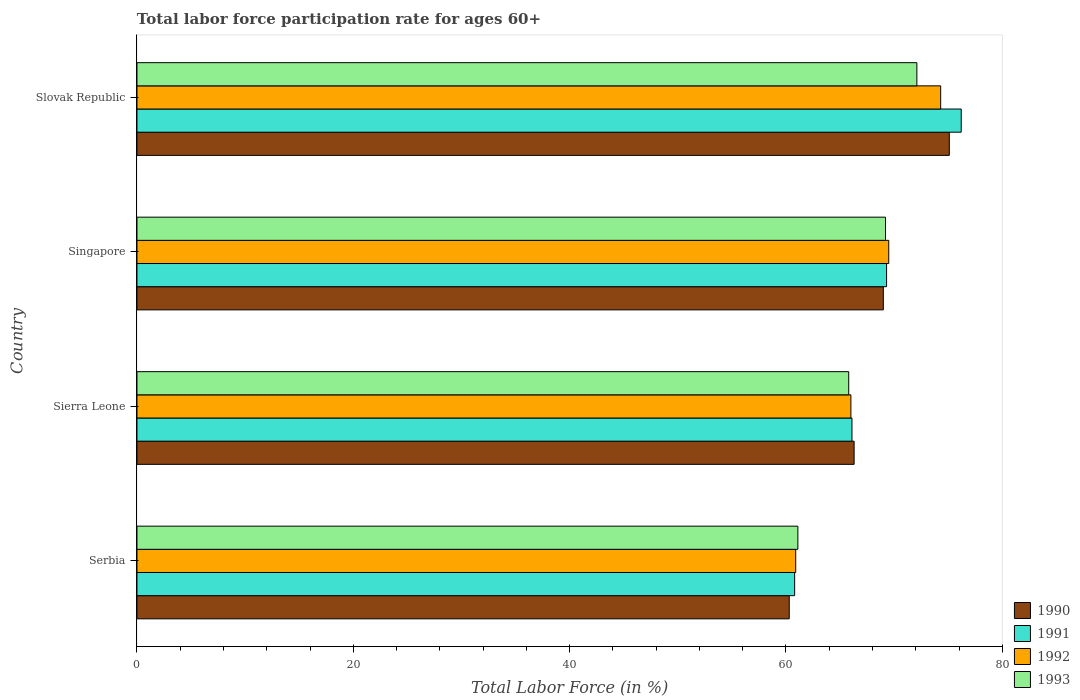How many different coloured bars are there?
Provide a succinct answer. 4. How many groups of bars are there?
Your answer should be very brief. 4. Are the number of bars on each tick of the Y-axis equal?
Offer a terse response. Yes. How many bars are there on the 1st tick from the top?
Offer a terse response. 4. How many bars are there on the 1st tick from the bottom?
Offer a terse response. 4. What is the label of the 1st group of bars from the top?
Your response must be concise. Slovak Republic. What is the labor force participation rate in 1993 in Slovak Republic?
Ensure brevity in your answer.  72.1. Across all countries, what is the maximum labor force participation rate in 1991?
Provide a short and direct response. 76.2. Across all countries, what is the minimum labor force participation rate in 1992?
Your response must be concise. 60.9. In which country was the labor force participation rate in 1993 maximum?
Give a very brief answer. Slovak Republic. In which country was the labor force participation rate in 1992 minimum?
Make the answer very short. Serbia. What is the total labor force participation rate in 1993 in the graph?
Keep it short and to the point. 268.2. What is the difference between the labor force participation rate in 1990 in Serbia and that in Sierra Leone?
Give a very brief answer. -6. What is the difference between the labor force participation rate in 1990 in Serbia and the labor force participation rate in 1992 in Slovak Republic?
Your answer should be compact. -14. What is the average labor force participation rate in 1992 per country?
Your answer should be very brief. 67.68. What is the difference between the labor force participation rate in 1992 and labor force participation rate in 1991 in Sierra Leone?
Provide a short and direct response. -0.1. In how many countries, is the labor force participation rate in 1990 greater than 4 %?
Offer a very short reply. 4. What is the ratio of the labor force participation rate in 1992 in Serbia to that in Slovak Republic?
Your answer should be very brief. 0.82. Is the labor force participation rate in 1993 in Serbia less than that in Sierra Leone?
Offer a very short reply. Yes. What is the difference between the highest and the second highest labor force participation rate in 1990?
Your answer should be very brief. 6.1. What is the difference between the highest and the lowest labor force participation rate in 1991?
Ensure brevity in your answer.  15.4. Is it the case that in every country, the sum of the labor force participation rate in 1993 and labor force participation rate in 1990 is greater than the sum of labor force participation rate in 1992 and labor force participation rate in 1991?
Offer a terse response. No. What does the 4th bar from the top in Slovak Republic represents?
Provide a short and direct response. 1990. Are all the bars in the graph horizontal?
Ensure brevity in your answer.  Yes. How many countries are there in the graph?
Make the answer very short. 4. What is the difference between two consecutive major ticks on the X-axis?
Give a very brief answer. 20. Are the values on the major ticks of X-axis written in scientific E-notation?
Offer a terse response. No. Does the graph contain any zero values?
Provide a succinct answer. No. Does the graph contain grids?
Make the answer very short. No. How are the legend labels stacked?
Your answer should be compact. Vertical. What is the title of the graph?
Offer a very short reply. Total labor force participation rate for ages 60+. Does "1971" appear as one of the legend labels in the graph?
Offer a very short reply. No. What is the Total Labor Force (in %) in 1990 in Serbia?
Offer a terse response. 60.3. What is the Total Labor Force (in %) in 1991 in Serbia?
Provide a succinct answer. 60.8. What is the Total Labor Force (in %) in 1992 in Serbia?
Give a very brief answer. 60.9. What is the Total Labor Force (in %) in 1993 in Serbia?
Provide a short and direct response. 61.1. What is the Total Labor Force (in %) of 1990 in Sierra Leone?
Offer a terse response. 66.3. What is the Total Labor Force (in %) of 1991 in Sierra Leone?
Your answer should be compact. 66.1. What is the Total Labor Force (in %) of 1992 in Sierra Leone?
Your response must be concise. 66. What is the Total Labor Force (in %) of 1993 in Sierra Leone?
Provide a short and direct response. 65.8. What is the Total Labor Force (in %) in 1990 in Singapore?
Your answer should be compact. 69. What is the Total Labor Force (in %) in 1991 in Singapore?
Your answer should be compact. 69.3. What is the Total Labor Force (in %) in 1992 in Singapore?
Your response must be concise. 69.5. What is the Total Labor Force (in %) in 1993 in Singapore?
Keep it short and to the point. 69.2. What is the Total Labor Force (in %) in 1990 in Slovak Republic?
Keep it short and to the point. 75.1. What is the Total Labor Force (in %) of 1991 in Slovak Republic?
Keep it short and to the point. 76.2. What is the Total Labor Force (in %) in 1992 in Slovak Republic?
Offer a very short reply. 74.3. What is the Total Labor Force (in %) of 1993 in Slovak Republic?
Offer a very short reply. 72.1. Across all countries, what is the maximum Total Labor Force (in %) in 1990?
Keep it short and to the point. 75.1. Across all countries, what is the maximum Total Labor Force (in %) in 1991?
Provide a succinct answer. 76.2. Across all countries, what is the maximum Total Labor Force (in %) of 1992?
Make the answer very short. 74.3. Across all countries, what is the maximum Total Labor Force (in %) of 1993?
Provide a succinct answer. 72.1. Across all countries, what is the minimum Total Labor Force (in %) in 1990?
Your answer should be very brief. 60.3. Across all countries, what is the minimum Total Labor Force (in %) in 1991?
Provide a short and direct response. 60.8. Across all countries, what is the minimum Total Labor Force (in %) of 1992?
Provide a short and direct response. 60.9. Across all countries, what is the minimum Total Labor Force (in %) in 1993?
Your answer should be very brief. 61.1. What is the total Total Labor Force (in %) of 1990 in the graph?
Provide a short and direct response. 270.7. What is the total Total Labor Force (in %) of 1991 in the graph?
Your answer should be very brief. 272.4. What is the total Total Labor Force (in %) in 1992 in the graph?
Your answer should be very brief. 270.7. What is the total Total Labor Force (in %) of 1993 in the graph?
Keep it short and to the point. 268.2. What is the difference between the Total Labor Force (in %) of 1991 in Serbia and that in Sierra Leone?
Make the answer very short. -5.3. What is the difference between the Total Labor Force (in %) of 1992 in Serbia and that in Sierra Leone?
Provide a short and direct response. -5.1. What is the difference between the Total Labor Force (in %) in 1993 in Serbia and that in Sierra Leone?
Keep it short and to the point. -4.7. What is the difference between the Total Labor Force (in %) of 1991 in Serbia and that in Singapore?
Make the answer very short. -8.5. What is the difference between the Total Labor Force (in %) of 1992 in Serbia and that in Singapore?
Make the answer very short. -8.6. What is the difference between the Total Labor Force (in %) of 1993 in Serbia and that in Singapore?
Keep it short and to the point. -8.1. What is the difference between the Total Labor Force (in %) of 1990 in Serbia and that in Slovak Republic?
Offer a terse response. -14.8. What is the difference between the Total Labor Force (in %) of 1991 in Serbia and that in Slovak Republic?
Your answer should be compact. -15.4. What is the difference between the Total Labor Force (in %) in 1992 in Serbia and that in Slovak Republic?
Make the answer very short. -13.4. What is the difference between the Total Labor Force (in %) in 1993 in Serbia and that in Slovak Republic?
Provide a succinct answer. -11. What is the difference between the Total Labor Force (in %) in 1990 in Sierra Leone and that in Singapore?
Provide a short and direct response. -2.7. What is the difference between the Total Labor Force (in %) in 1991 in Sierra Leone and that in Slovak Republic?
Keep it short and to the point. -10.1. What is the difference between the Total Labor Force (in %) in 1992 in Sierra Leone and that in Slovak Republic?
Your answer should be very brief. -8.3. What is the difference between the Total Labor Force (in %) in 1993 in Sierra Leone and that in Slovak Republic?
Provide a succinct answer. -6.3. What is the difference between the Total Labor Force (in %) in 1990 in Singapore and that in Slovak Republic?
Make the answer very short. -6.1. What is the difference between the Total Labor Force (in %) of 1991 in Singapore and that in Slovak Republic?
Your answer should be very brief. -6.9. What is the difference between the Total Labor Force (in %) in 1992 in Singapore and that in Slovak Republic?
Keep it short and to the point. -4.8. What is the difference between the Total Labor Force (in %) of 1993 in Singapore and that in Slovak Republic?
Offer a very short reply. -2.9. What is the difference between the Total Labor Force (in %) of 1990 in Serbia and the Total Labor Force (in %) of 1992 in Sierra Leone?
Keep it short and to the point. -5.7. What is the difference between the Total Labor Force (in %) in 1991 in Serbia and the Total Labor Force (in %) in 1993 in Sierra Leone?
Offer a very short reply. -5. What is the difference between the Total Labor Force (in %) of 1990 in Serbia and the Total Labor Force (in %) of 1991 in Singapore?
Your answer should be very brief. -9. What is the difference between the Total Labor Force (in %) of 1990 in Serbia and the Total Labor Force (in %) of 1992 in Singapore?
Your answer should be very brief. -9.2. What is the difference between the Total Labor Force (in %) in 1991 in Serbia and the Total Labor Force (in %) in 1992 in Singapore?
Your answer should be compact. -8.7. What is the difference between the Total Labor Force (in %) in 1991 in Serbia and the Total Labor Force (in %) in 1993 in Singapore?
Offer a very short reply. -8.4. What is the difference between the Total Labor Force (in %) in 1990 in Serbia and the Total Labor Force (in %) in 1991 in Slovak Republic?
Give a very brief answer. -15.9. What is the difference between the Total Labor Force (in %) in 1991 in Serbia and the Total Labor Force (in %) in 1992 in Slovak Republic?
Your answer should be very brief. -13.5. What is the difference between the Total Labor Force (in %) in 1991 in Sierra Leone and the Total Labor Force (in %) in 1992 in Singapore?
Your response must be concise. -3.4. What is the difference between the Total Labor Force (in %) in 1991 in Sierra Leone and the Total Labor Force (in %) in 1993 in Singapore?
Your response must be concise. -3.1. What is the difference between the Total Labor Force (in %) of 1992 in Sierra Leone and the Total Labor Force (in %) of 1993 in Singapore?
Provide a succinct answer. -3.2. What is the difference between the Total Labor Force (in %) of 1991 in Sierra Leone and the Total Labor Force (in %) of 1992 in Slovak Republic?
Keep it short and to the point. -8.2. What is the difference between the Total Labor Force (in %) in 1991 in Sierra Leone and the Total Labor Force (in %) in 1993 in Slovak Republic?
Give a very brief answer. -6. What is the difference between the Total Labor Force (in %) in 1990 in Singapore and the Total Labor Force (in %) in 1993 in Slovak Republic?
Provide a short and direct response. -3.1. What is the difference between the Total Labor Force (in %) of 1992 in Singapore and the Total Labor Force (in %) of 1993 in Slovak Republic?
Offer a very short reply. -2.6. What is the average Total Labor Force (in %) of 1990 per country?
Make the answer very short. 67.67. What is the average Total Labor Force (in %) of 1991 per country?
Ensure brevity in your answer.  68.1. What is the average Total Labor Force (in %) of 1992 per country?
Provide a short and direct response. 67.67. What is the average Total Labor Force (in %) in 1993 per country?
Your response must be concise. 67.05. What is the difference between the Total Labor Force (in %) in 1990 and Total Labor Force (in %) in 1991 in Serbia?
Provide a succinct answer. -0.5. What is the difference between the Total Labor Force (in %) in 1990 and Total Labor Force (in %) in 1992 in Serbia?
Your answer should be compact. -0.6. What is the difference between the Total Labor Force (in %) in 1990 and Total Labor Force (in %) in 1993 in Serbia?
Keep it short and to the point. -0.8. What is the difference between the Total Labor Force (in %) in 1991 and Total Labor Force (in %) in 1993 in Serbia?
Ensure brevity in your answer.  -0.3. What is the difference between the Total Labor Force (in %) in 1990 and Total Labor Force (in %) in 1992 in Singapore?
Ensure brevity in your answer.  -0.5. What is the difference between the Total Labor Force (in %) of 1991 and Total Labor Force (in %) of 1993 in Singapore?
Make the answer very short. 0.1. What is the difference between the Total Labor Force (in %) in 1990 and Total Labor Force (in %) in 1991 in Slovak Republic?
Your response must be concise. -1.1. What is the difference between the Total Labor Force (in %) in 1990 and Total Labor Force (in %) in 1992 in Slovak Republic?
Ensure brevity in your answer.  0.8. What is the difference between the Total Labor Force (in %) of 1990 and Total Labor Force (in %) of 1993 in Slovak Republic?
Keep it short and to the point. 3. What is the difference between the Total Labor Force (in %) in 1992 and Total Labor Force (in %) in 1993 in Slovak Republic?
Give a very brief answer. 2.2. What is the ratio of the Total Labor Force (in %) in 1990 in Serbia to that in Sierra Leone?
Your answer should be very brief. 0.91. What is the ratio of the Total Labor Force (in %) in 1991 in Serbia to that in Sierra Leone?
Your response must be concise. 0.92. What is the ratio of the Total Labor Force (in %) of 1992 in Serbia to that in Sierra Leone?
Make the answer very short. 0.92. What is the ratio of the Total Labor Force (in %) in 1993 in Serbia to that in Sierra Leone?
Give a very brief answer. 0.93. What is the ratio of the Total Labor Force (in %) of 1990 in Serbia to that in Singapore?
Give a very brief answer. 0.87. What is the ratio of the Total Labor Force (in %) in 1991 in Serbia to that in Singapore?
Your response must be concise. 0.88. What is the ratio of the Total Labor Force (in %) of 1992 in Serbia to that in Singapore?
Your response must be concise. 0.88. What is the ratio of the Total Labor Force (in %) in 1993 in Serbia to that in Singapore?
Offer a terse response. 0.88. What is the ratio of the Total Labor Force (in %) of 1990 in Serbia to that in Slovak Republic?
Keep it short and to the point. 0.8. What is the ratio of the Total Labor Force (in %) in 1991 in Serbia to that in Slovak Republic?
Give a very brief answer. 0.8. What is the ratio of the Total Labor Force (in %) of 1992 in Serbia to that in Slovak Republic?
Provide a short and direct response. 0.82. What is the ratio of the Total Labor Force (in %) in 1993 in Serbia to that in Slovak Republic?
Provide a short and direct response. 0.85. What is the ratio of the Total Labor Force (in %) in 1990 in Sierra Leone to that in Singapore?
Provide a short and direct response. 0.96. What is the ratio of the Total Labor Force (in %) of 1991 in Sierra Leone to that in Singapore?
Keep it short and to the point. 0.95. What is the ratio of the Total Labor Force (in %) of 1992 in Sierra Leone to that in Singapore?
Ensure brevity in your answer.  0.95. What is the ratio of the Total Labor Force (in %) of 1993 in Sierra Leone to that in Singapore?
Keep it short and to the point. 0.95. What is the ratio of the Total Labor Force (in %) in 1990 in Sierra Leone to that in Slovak Republic?
Keep it short and to the point. 0.88. What is the ratio of the Total Labor Force (in %) in 1991 in Sierra Leone to that in Slovak Republic?
Provide a succinct answer. 0.87. What is the ratio of the Total Labor Force (in %) of 1992 in Sierra Leone to that in Slovak Republic?
Give a very brief answer. 0.89. What is the ratio of the Total Labor Force (in %) of 1993 in Sierra Leone to that in Slovak Republic?
Ensure brevity in your answer.  0.91. What is the ratio of the Total Labor Force (in %) in 1990 in Singapore to that in Slovak Republic?
Offer a terse response. 0.92. What is the ratio of the Total Labor Force (in %) in 1991 in Singapore to that in Slovak Republic?
Your answer should be compact. 0.91. What is the ratio of the Total Labor Force (in %) of 1992 in Singapore to that in Slovak Republic?
Offer a very short reply. 0.94. What is the ratio of the Total Labor Force (in %) in 1993 in Singapore to that in Slovak Republic?
Provide a short and direct response. 0.96. What is the difference between the highest and the second highest Total Labor Force (in %) in 1992?
Provide a short and direct response. 4.8. What is the difference between the highest and the second highest Total Labor Force (in %) of 1993?
Offer a terse response. 2.9. What is the difference between the highest and the lowest Total Labor Force (in %) of 1992?
Keep it short and to the point. 13.4. What is the difference between the highest and the lowest Total Labor Force (in %) in 1993?
Offer a very short reply. 11. 